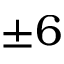<formula> <loc_0><loc_0><loc_500><loc_500>\pm 6</formula> 